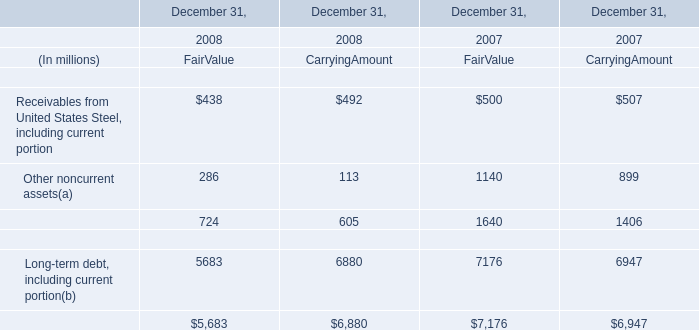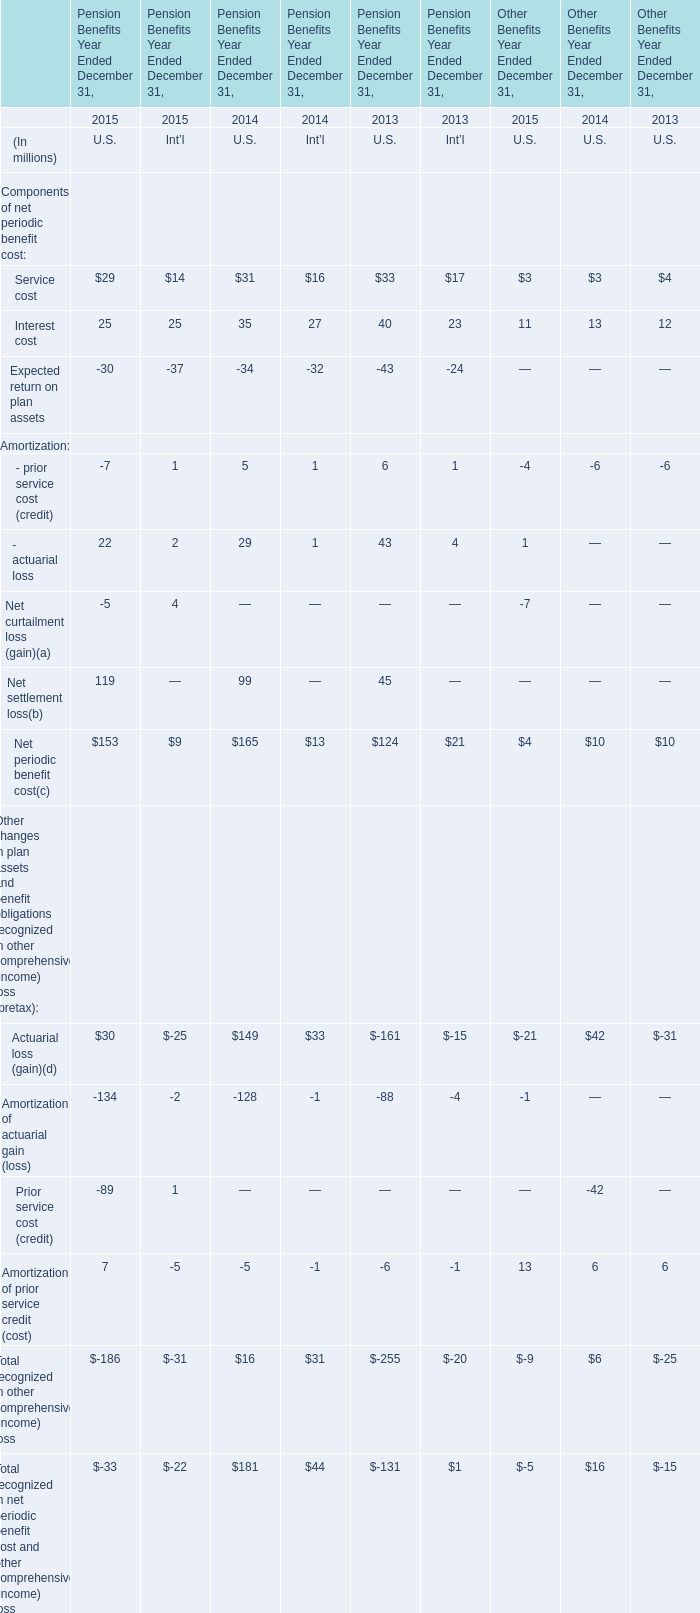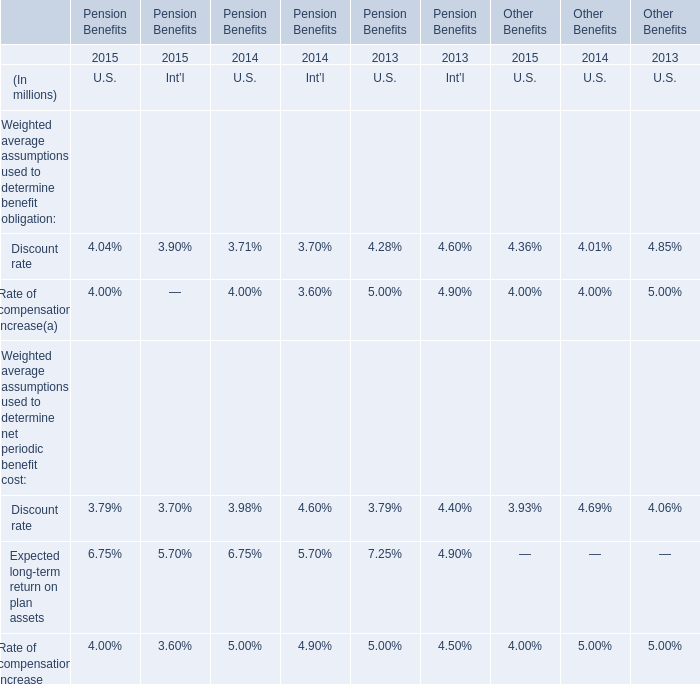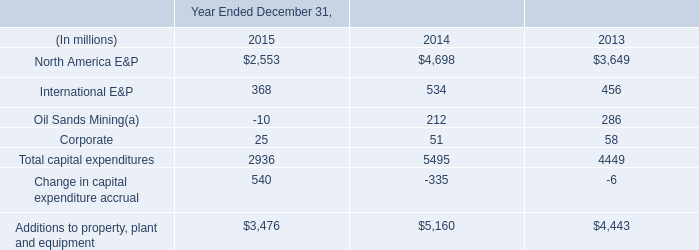When is Interest cost the largest for Pension Benefits Year Ended December 31,for U.S. ? 
Answer: 2013. 